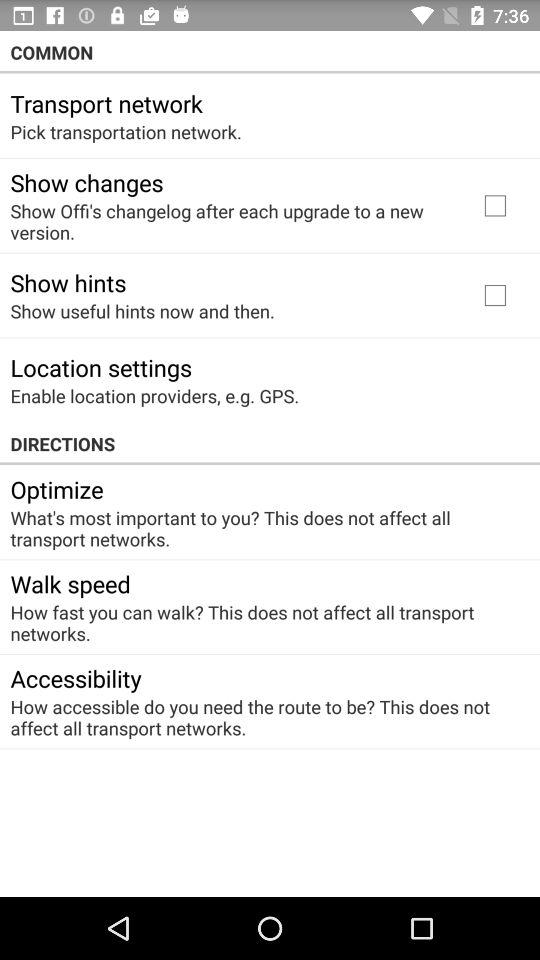What's the status of the show hints? The status is off. 